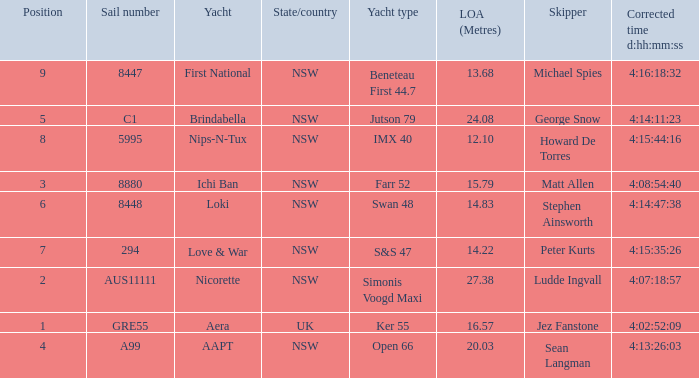Which racing boat had a corrected time of 4:14:11:23? Brindabella. 